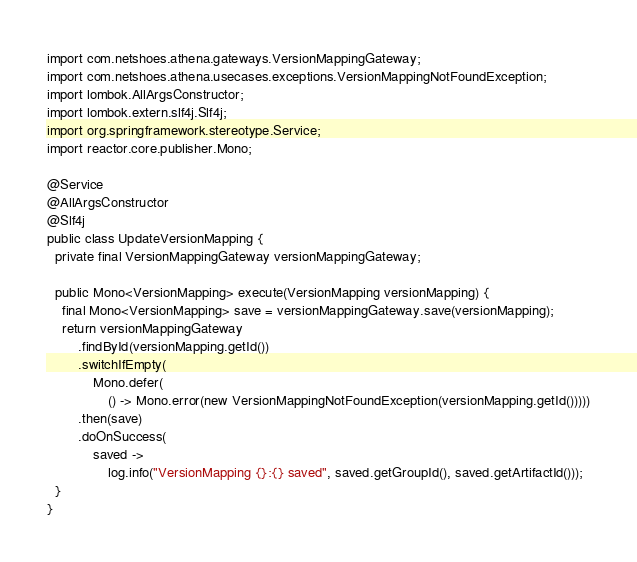Convert code to text. <code><loc_0><loc_0><loc_500><loc_500><_Java_>import com.netshoes.athena.gateways.VersionMappingGateway;
import com.netshoes.athena.usecases.exceptions.VersionMappingNotFoundException;
import lombok.AllArgsConstructor;
import lombok.extern.slf4j.Slf4j;
import org.springframework.stereotype.Service;
import reactor.core.publisher.Mono;

@Service
@AllArgsConstructor
@Slf4j
public class UpdateVersionMapping {
  private final VersionMappingGateway versionMappingGateway;

  public Mono<VersionMapping> execute(VersionMapping versionMapping) {
    final Mono<VersionMapping> save = versionMappingGateway.save(versionMapping);
    return versionMappingGateway
        .findById(versionMapping.getId())
        .switchIfEmpty(
            Mono.defer(
                () -> Mono.error(new VersionMappingNotFoundException(versionMapping.getId()))))
        .then(save)
        .doOnSuccess(
            saved ->
                log.info("VersionMapping {}:{} saved", saved.getGroupId(), saved.getArtifactId()));
  }
}
</code> 